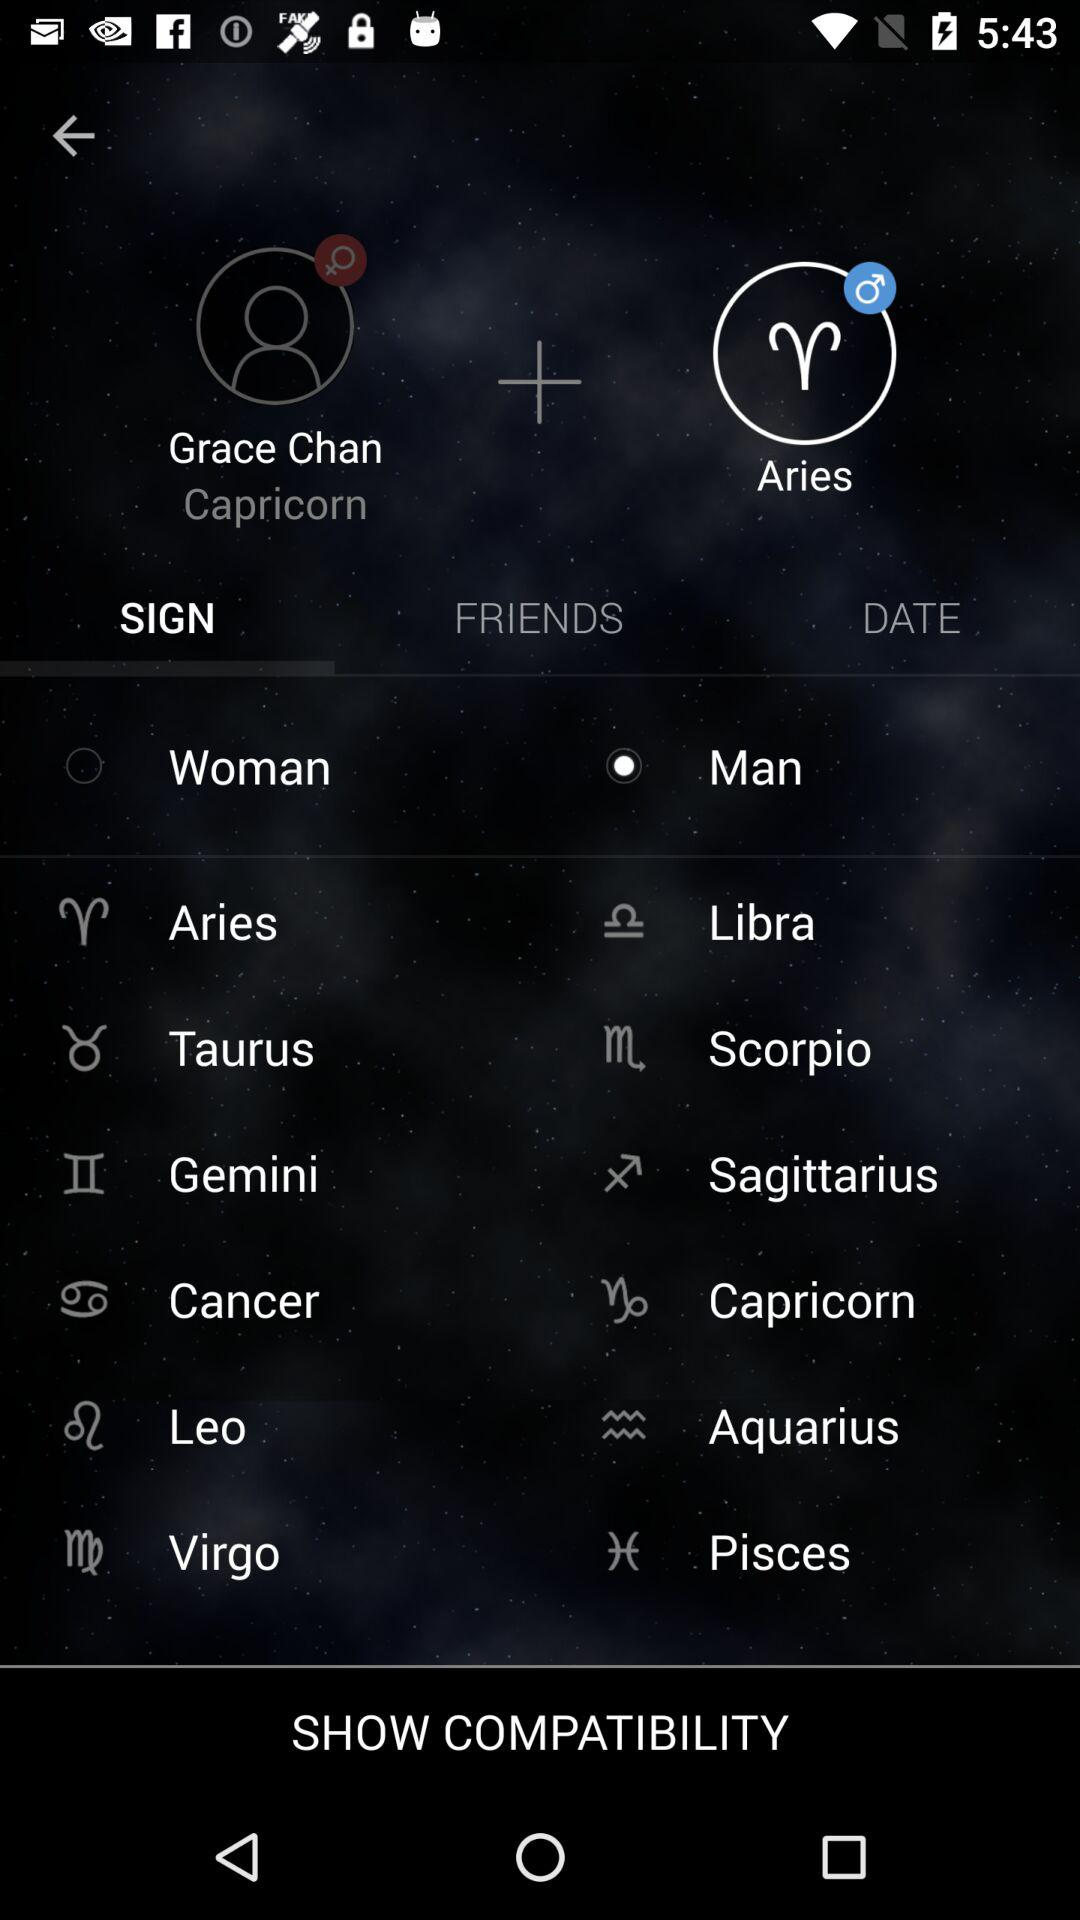Who is listed as a friend?
When the provided information is insufficient, respond with <no answer>. <no answer> 